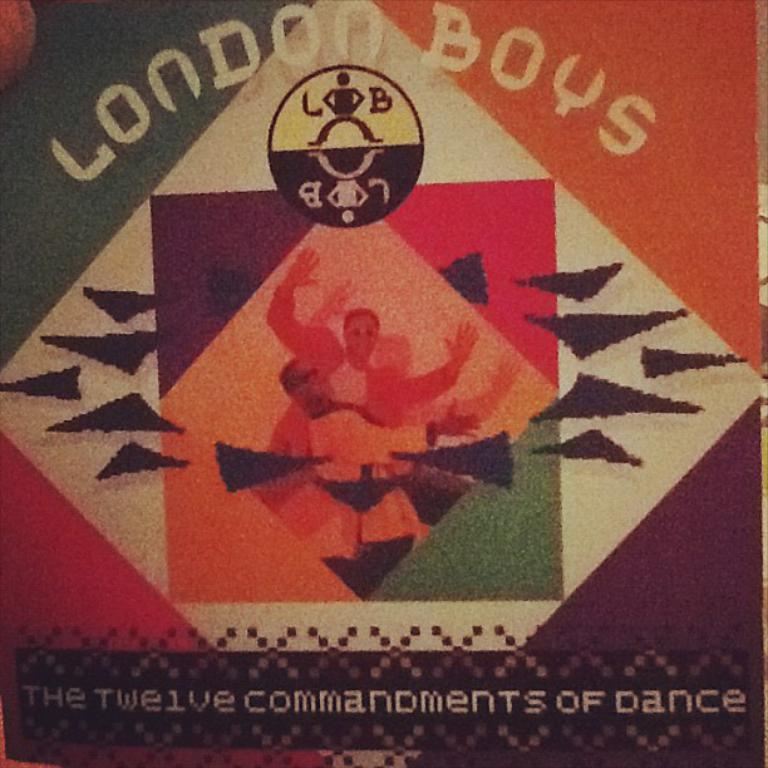<image>
Relay a brief, clear account of the picture shown. A London Boys album called The Twelve Commandments of Dance show a couple of men with arms raised. 